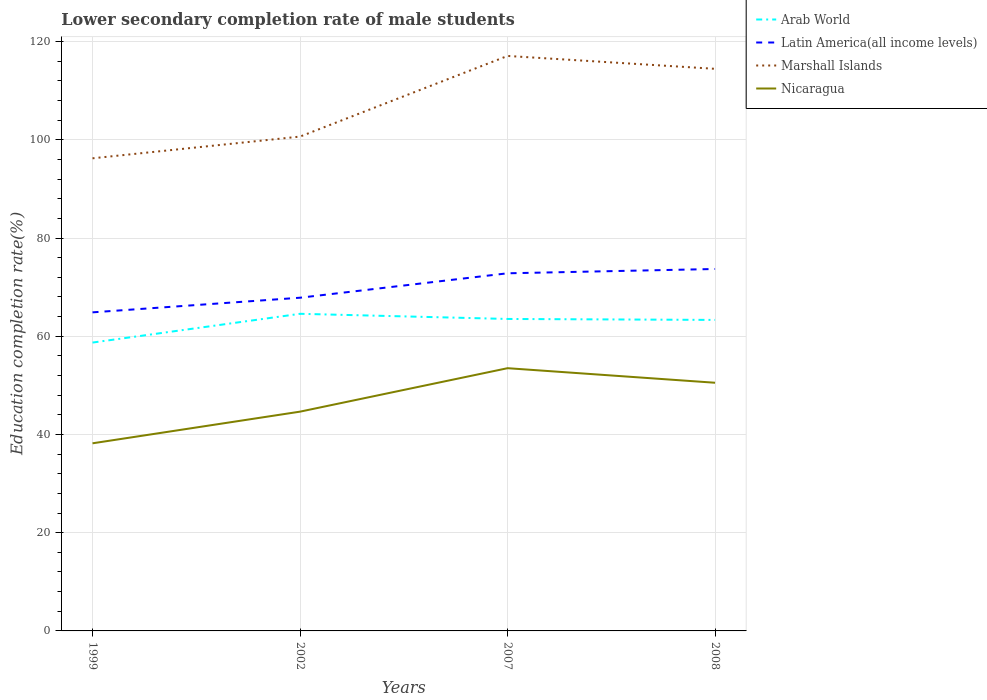Does the line corresponding to Marshall Islands intersect with the line corresponding to Nicaragua?
Your answer should be compact. No. Is the number of lines equal to the number of legend labels?
Give a very brief answer. Yes. Across all years, what is the maximum lower secondary completion rate of male students in Arab World?
Provide a short and direct response. 58.71. In which year was the lower secondary completion rate of male students in Marshall Islands maximum?
Provide a succinct answer. 1999. What is the total lower secondary completion rate of male students in Arab World in the graph?
Offer a terse response. 0.2. What is the difference between the highest and the second highest lower secondary completion rate of male students in Latin America(all income levels)?
Offer a very short reply. 8.83. What is the difference between the highest and the lowest lower secondary completion rate of male students in Nicaragua?
Provide a succinct answer. 2. Is the lower secondary completion rate of male students in Nicaragua strictly greater than the lower secondary completion rate of male students in Arab World over the years?
Your answer should be compact. Yes. What is the difference between two consecutive major ticks on the Y-axis?
Your response must be concise. 20. Are the values on the major ticks of Y-axis written in scientific E-notation?
Ensure brevity in your answer.  No. Does the graph contain grids?
Your answer should be compact. Yes. Where does the legend appear in the graph?
Your response must be concise. Top right. How many legend labels are there?
Make the answer very short. 4. What is the title of the graph?
Your answer should be compact. Lower secondary completion rate of male students. What is the label or title of the Y-axis?
Provide a short and direct response. Education completion rate(%). What is the Education completion rate(%) of Arab World in 1999?
Your answer should be compact. 58.71. What is the Education completion rate(%) of Latin America(all income levels) in 1999?
Your response must be concise. 64.86. What is the Education completion rate(%) in Marshall Islands in 1999?
Your response must be concise. 96.23. What is the Education completion rate(%) in Nicaragua in 1999?
Offer a terse response. 38.2. What is the Education completion rate(%) of Arab World in 2002?
Keep it short and to the point. 64.57. What is the Education completion rate(%) in Latin America(all income levels) in 2002?
Provide a short and direct response. 67.84. What is the Education completion rate(%) of Marshall Islands in 2002?
Give a very brief answer. 100.65. What is the Education completion rate(%) of Nicaragua in 2002?
Provide a succinct answer. 44.65. What is the Education completion rate(%) in Arab World in 2007?
Your answer should be compact. 63.52. What is the Education completion rate(%) in Latin America(all income levels) in 2007?
Offer a terse response. 72.81. What is the Education completion rate(%) of Marshall Islands in 2007?
Your answer should be compact. 117.07. What is the Education completion rate(%) of Nicaragua in 2007?
Make the answer very short. 53.49. What is the Education completion rate(%) of Arab World in 2008?
Offer a very short reply. 63.32. What is the Education completion rate(%) in Latin America(all income levels) in 2008?
Your response must be concise. 73.69. What is the Education completion rate(%) in Marshall Islands in 2008?
Offer a terse response. 114.44. What is the Education completion rate(%) in Nicaragua in 2008?
Your answer should be very brief. 50.53. Across all years, what is the maximum Education completion rate(%) in Arab World?
Your answer should be very brief. 64.57. Across all years, what is the maximum Education completion rate(%) in Latin America(all income levels)?
Offer a very short reply. 73.69. Across all years, what is the maximum Education completion rate(%) of Marshall Islands?
Offer a terse response. 117.07. Across all years, what is the maximum Education completion rate(%) in Nicaragua?
Keep it short and to the point. 53.49. Across all years, what is the minimum Education completion rate(%) in Arab World?
Give a very brief answer. 58.71. Across all years, what is the minimum Education completion rate(%) of Latin America(all income levels)?
Offer a very short reply. 64.86. Across all years, what is the minimum Education completion rate(%) of Marshall Islands?
Give a very brief answer. 96.23. Across all years, what is the minimum Education completion rate(%) of Nicaragua?
Provide a succinct answer. 38.2. What is the total Education completion rate(%) in Arab World in the graph?
Provide a succinct answer. 250.12. What is the total Education completion rate(%) of Latin America(all income levels) in the graph?
Your answer should be compact. 279.21. What is the total Education completion rate(%) of Marshall Islands in the graph?
Make the answer very short. 428.39. What is the total Education completion rate(%) of Nicaragua in the graph?
Provide a succinct answer. 186.87. What is the difference between the Education completion rate(%) in Arab World in 1999 and that in 2002?
Your response must be concise. -5.85. What is the difference between the Education completion rate(%) of Latin America(all income levels) in 1999 and that in 2002?
Your response must be concise. -2.98. What is the difference between the Education completion rate(%) in Marshall Islands in 1999 and that in 2002?
Provide a succinct answer. -4.42. What is the difference between the Education completion rate(%) in Nicaragua in 1999 and that in 2002?
Your answer should be very brief. -6.45. What is the difference between the Education completion rate(%) of Arab World in 1999 and that in 2007?
Keep it short and to the point. -4.81. What is the difference between the Education completion rate(%) of Latin America(all income levels) in 1999 and that in 2007?
Offer a terse response. -7.95. What is the difference between the Education completion rate(%) of Marshall Islands in 1999 and that in 2007?
Make the answer very short. -20.84. What is the difference between the Education completion rate(%) in Nicaragua in 1999 and that in 2007?
Your answer should be compact. -15.29. What is the difference between the Education completion rate(%) of Arab World in 1999 and that in 2008?
Provide a succinct answer. -4.61. What is the difference between the Education completion rate(%) of Latin America(all income levels) in 1999 and that in 2008?
Offer a terse response. -8.83. What is the difference between the Education completion rate(%) of Marshall Islands in 1999 and that in 2008?
Offer a terse response. -18.22. What is the difference between the Education completion rate(%) of Nicaragua in 1999 and that in 2008?
Your answer should be compact. -12.33. What is the difference between the Education completion rate(%) of Arab World in 2002 and that in 2007?
Provide a short and direct response. 1.05. What is the difference between the Education completion rate(%) in Latin America(all income levels) in 2002 and that in 2007?
Your answer should be compact. -4.97. What is the difference between the Education completion rate(%) in Marshall Islands in 2002 and that in 2007?
Your answer should be very brief. -16.42. What is the difference between the Education completion rate(%) of Nicaragua in 2002 and that in 2007?
Keep it short and to the point. -8.85. What is the difference between the Education completion rate(%) in Arab World in 2002 and that in 2008?
Provide a succinct answer. 1.25. What is the difference between the Education completion rate(%) in Latin America(all income levels) in 2002 and that in 2008?
Give a very brief answer. -5.85. What is the difference between the Education completion rate(%) of Marshall Islands in 2002 and that in 2008?
Make the answer very short. -13.79. What is the difference between the Education completion rate(%) of Nicaragua in 2002 and that in 2008?
Offer a very short reply. -5.88. What is the difference between the Education completion rate(%) in Arab World in 2007 and that in 2008?
Give a very brief answer. 0.2. What is the difference between the Education completion rate(%) in Latin America(all income levels) in 2007 and that in 2008?
Your answer should be compact. -0.88. What is the difference between the Education completion rate(%) of Marshall Islands in 2007 and that in 2008?
Ensure brevity in your answer.  2.62. What is the difference between the Education completion rate(%) in Nicaragua in 2007 and that in 2008?
Make the answer very short. 2.96. What is the difference between the Education completion rate(%) in Arab World in 1999 and the Education completion rate(%) in Latin America(all income levels) in 2002?
Provide a succinct answer. -9.13. What is the difference between the Education completion rate(%) of Arab World in 1999 and the Education completion rate(%) of Marshall Islands in 2002?
Keep it short and to the point. -41.94. What is the difference between the Education completion rate(%) in Arab World in 1999 and the Education completion rate(%) in Nicaragua in 2002?
Make the answer very short. 14.07. What is the difference between the Education completion rate(%) in Latin America(all income levels) in 1999 and the Education completion rate(%) in Marshall Islands in 2002?
Keep it short and to the point. -35.79. What is the difference between the Education completion rate(%) of Latin America(all income levels) in 1999 and the Education completion rate(%) of Nicaragua in 2002?
Offer a very short reply. 20.22. What is the difference between the Education completion rate(%) of Marshall Islands in 1999 and the Education completion rate(%) of Nicaragua in 2002?
Provide a short and direct response. 51.58. What is the difference between the Education completion rate(%) of Arab World in 1999 and the Education completion rate(%) of Latin America(all income levels) in 2007?
Keep it short and to the point. -14.1. What is the difference between the Education completion rate(%) in Arab World in 1999 and the Education completion rate(%) in Marshall Islands in 2007?
Keep it short and to the point. -58.36. What is the difference between the Education completion rate(%) in Arab World in 1999 and the Education completion rate(%) in Nicaragua in 2007?
Provide a short and direct response. 5.22. What is the difference between the Education completion rate(%) of Latin America(all income levels) in 1999 and the Education completion rate(%) of Marshall Islands in 2007?
Keep it short and to the point. -52.2. What is the difference between the Education completion rate(%) in Latin America(all income levels) in 1999 and the Education completion rate(%) in Nicaragua in 2007?
Your response must be concise. 11.37. What is the difference between the Education completion rate(%) of Marshall Islands in 1999 and the Education completion rate(%) of Nicaragua in 2007?
Provide a short and direct response. 42.73. What is the difference between the Education completion rate(%) in Arab World in 1999 and the Education completion rate(%) in Latin America(all income levels) in 2008?
Your response must be concise. -14.98. What is the difference between the Education completion rate(%) in Arab World in 1999 and the Education completion rate(%) in Marshall Islands in 2008?
Make the answer very short. -55.73. What is the difference between the Education completion rate(%) of Arab World in 1999 and the Education completion rate(%) of Nicaragua in 2008?
Keep it short and to the point. 8.18. What is the difference between the Education completion rate(%) of Latin America(all income levels) in 1999 and the Education completion rate(%) of Marshall Islands in 2008?
Keep it short and to the point. -49.58. What is the difference between the Education completion rate(%) in Latin America(all income levels) in 1999 and the Education completion rate(%) in Nicaragua in 2008?
Your answer should be very brief. 14.33. What is the difference between the Education completion rate(%) in Marshall Islands in 1999 and the Education completion rate(%) in Nicaragua in 2008?
Make the answer very short. 45.7. What is the difference between the Education completion rate(%) of Arab World in 2002 and the Education completion rate(%) of Latin America(all income levels) in 2007?
Provide a succinct answer. -8.25. What is the difference between the Education completion rate(%) of Arab World in 2002 and the Education completion rate(%) of Marshall Islands in 2007?
Your response must be concise. -52.5. What is the difference between the Education completion rate(%) of Arab World in 2002 and the Education completion rate(%) of Nicaragua in 2007?
Offer a terse response. 11.07. What is the difference between the Education completion rate(%) of Latin America(all income levels) in 2002 and the Education completion rate(%) of Marshall Islands in 2007?
Keep it short and to the point. -49.23. What is the difference between the Education completion rate(%) of Latin America(all income levels) in 2002 and the Education completion rate(%) of Nicaragua in 2007?
Provide a succinct answer. 14.35. What is the difference between the Education completion rate(%) in Marshall Islands in 2002 and the Education completion rate(%) in Nicaragua in 2007?
Provide a succinct answer. 47.16. What is the difference between the Education completion rate(%) of Arab World in 2002 and the Education completion rate(%) of Latin America(all income levels) in 2008?
Ensure brevity in your answer.  -9.12. What is the difference between the Education completion rate(%) in Arab World in 2002 and the Education completion rate(%) in Marshall Islands in 2008?
Ensure brevity in your answer.  -49.88. What is the difference between the Education completion rate(%) in Arab World in 2002 and the Education completion rate(%) in Nicaragua in 2008?
Make the answer very short. 14.04. What is the difference between the Education completion rate(%) in Latin America(all income levels) in 2002 and the Education completion rate(%) in Marshall Islands in 2008?
Offer a terse response. -46.6. What is the difference between the Education completion rate(%) in Latin America(all income levels) in 2002 and the Education completion rate(%) in Nicaragua in 2008?
Offer a very short reply. 17.31. What is the difference between the Education completion rate(%) in Marshall Islands in 2002 and the Education completion rate(%) in Nicaragua in 2008?
Your answer should be compact. 50.12. What is the difference between the Education completion rate(%) in Arab World in 2007 and the Education completion rate(%) in Latin America(all income levels) in 2008?
Provide a succinct answer. -10.17. What is the difference between the Education completion rate(%) in Arab World in 2007 and the Education completion rate(%) in Marshall Islands in 2008?
Your response must be concise. -50.93. What is the difference between the Education completion rate(%) of Arab World in 2007 and the Education completion rate(%) of Nicaragua in 2008?
Provide a succinct answer. 12.99. What is the difference between the Education completion rate(%) in Latin America(all income levels) in 2007 and the Education completion rate(%) in Marshall Islands in 2008?
Your answer should be compact. -41.63. What is the difference between the Education completion rate(%) in Latin America(all income levels) in 2007 and the Education completion rate(%) in Nicaragua in 2008?
Provide a short and direct response. 22.29. What is the difference between the Education completion rate(%) in Marshall Islands in 2007 and the Education completion rate(%) in Nicaragua in 2008?
Provide a succinct answer. 66.54. What is the average Education completion rate(%) of Arab World per year?
Ensure brevity in your answer.  62.53. What is the average Education completion rate(%) of Latin America(all income levels) per year?
Provide a short and direct response. 69.8. What is the average Education completion rate(%) in Marshall Islands per year?
Your answer should be very brief. 107.1. What is the average Education completion rate(%) in Nicaragua per year?
Your answer should be very brief. 46.72. In the year 1999, what is the difference between the Education completion rate(%) in Arab World and Education completion rate(%) in Latin America(all income levels)?
Keep it short and to the point. -6.15. In the year 1999, what is the difference between the Education completion rate(%) of Arab World and Education completion rate(%) of Marshall Islands?
Your answer should be compact. -37.51. In the year 1999, what is the difference between the Education completion rate(%) in Arab World and Education completion rate(%) in Nicaragua?
Keep it short and to the point. 20.51. In the year 1999, what is the difference between the Education completion rate(%) of Latin America(all income levels) and Education completion rate(%) of Marshall Islands?
Your answer should be compact. -31.36. In the year 1999, what is the difference between the Education completion rate(%) of Latin America(all income levels) and Education completion rate(%) of Nicaragua?
Make the answer very short. 26.66. In the year 1999, what is the difference between the Education completion rate(%) of Marshall Islands and Education completion rate(%) of Nicaragua?
Make the answer very short. 58.03. In the year 2002, what is the difference between the Education completion rate(%) of Arab World and Education completion rate(%) of Latin America(all income levels)?
Give a very brief answer. -3.28. In the year 2002, what is the difference between the Education completion rate(%) of Arab World and Education completion rate(%) of Marshall Islands?
Offer a very short reply. -36.08. In the year 2002, what is the difference between the Education completion rate(%) in Arab World and Education completion rate(%) in Nicaragua?
Your response must be concise. 19.92. In the year 2002, what is the difference between the Education completion rate(%) of Latin America(all income levels) and Education completion rate(%) of Marshall Islands?
Offer a terse response. -32.81. In the year 2002, what is the difference between the Education completion rate(%) in Latin America(all income levels) and Education completion rate(%) in Nicaragua?
Make the answer very short. 23.2. In the year 2002, what is the difference between the Education completion rate(%) of Marshall Islands and Education completion rate(%) of Nicaragua?
Make the answer very short. 56.01. In the year 2007, what is the difference between the Education completion rate(%) of Arab World and Education completion rate(%) of Latin America(all income levels)?
Make the answer very short. -9.3. In the year 2007, what is the difference between the Education completion rate(%) of Arab World and Education completion rate(%) of Marshall Islands?
Ensure brevity in your answer.  -53.55. In the year 2007, what is the difference between the Education completion rate(%) in Arab World and Education completion rate(%) in Nicaragua?
Offer a very short reply. 10.02. In the year 2007, what is the difference between the Education completion rate(%) of Latin America(all income levels) and Education completion rate(%) of Marshall Islands?
Provide a succinct answer. -44.25. In the year 2007, what is the difference between the Education completion rate(%) in Latin America(all income levels) and Education completion rate(%) in Nicaragua?
Provide a short and direct response. 19.32. In the year 2007, what is the difference between the Education completion rate(%) in Marshall Islands and Education completion rate(%) in Nicaragua?
Offer a very short reply. 63.58. In the year 2008, what is the difference between the Education completion rate(%) of Arab World and Education completion rate(%) of Latin America(all income levels)?
Your answer should be very brief. -10.37. In the year 2008, what is the difference between the Education completion rate(%) in Arab World and Education completion rate(%) in Marshall Islands?
Keep it short and to the point. -51.12. In the year 2008, what is the difference between the Education completion rate(%) of Arab World and Education completion rate(%) of Nicaragua?
Give a very brief answer. 12.79. In the year 2008, what is the difference between the Education completion rate(%) of Latin America(all income levels) and Education completion rate(%) of Marshall Islands?
Give a very brief answer. -40.75. In the year 2008, what is the difference between the Education completion rate(%) in Latin America(all income levels) and Education completion rate(%) in Nicaragua?
Make the answer very short. 23.16. In the year 2008, what is the difference between the Education completion rate(%) in Marshall Islands and Education completion rate(%) in Nicaragua?
Offer a terse response. 63.91. What is the ratio of the Education completion rate(%) of Arab World in 1999 to that in 2002?
Keep it short and to the point. 0.91. What is the ratio of the Education completion rate(%) of Latin America(all income levels) in 1999 to that in 2002?
Give a very brief answer. 0.96. What is the ratio of the Education completion rate(%) of Marshall Islands in 1999 to that in 2002?
Your answer should be very brief. 0.96. What is the ratio of the Education completion rate(%) of Nicaragua in 1999 to that in 2002?
Make the answer very short. 0.86. What is the ratio of the Education completion rate(%) of Arab World in 1999 to that in 2007?
Your response must be concise. 0.92. What is the ratio of the Education completion rate(%) of Latin America(all income levels) in 1999 to that in 2007?
Your answer should be very brief. 0.89. What is the ratio of the Education completion rate(%) in Marshall Islands in 1999 to that in 2007?
Your answer should be very brief. 0.82. What is the ratio of the Education completion rate(%) of Nicaragua in 1999 to that in 2007?
Give a very brief answer. 0.71. What is the ratio of the Education completion rate(%) in Arab World in 1999 to that in 2008?
Make the answer very short. 0.93. What is the ratio of the Education completion rate(%) of Latin America(all income levels) in 1999 to that in 2008?
Offer a terse response. 0.88. What is the ratio of the Education completion rate(%) in Marshall Islands in 1999 to that in 2008?
Your response must be concise. 0.84. What is the ratio of the Education completion rate(%) of Nicaragua in 1999 to that in 2008?
Offer a terse response. 0.76. What is the ratio of the Education completion rate(%) in Arab World in 2002 to that in 2007?
Ensure brevity in your answer.  1.02. What is the ratio of the Education completion rate(%) in Latin America(all income levels) in 2002 to that in 2007?
Offer a very short reply. 0.93. What is the ratio of the Education completion rate(%) of Marshall Islands in 2002 to that in 2007?
Offer a terse response. 0.86. What is the ratio of the Education completion rate(%) in Nicaragua in 2002 to that in 2007?
Keep it short and to the point. 0.83. What is the ratio of the Education completion rate(%) of Arab World in 2002 to that in 2008?
Your answer should be very brief. 1.02. What is the ratio of the Education completion rate(%) in Latin America(all income levels) in 2002 to that in 2008?
Your response must be concise. 0.92. What is the ratio of the Education completion rate(%) of Marshall Islands in 2002 to that in 2008?
Offer a very short reply. 0.88. What is the ratio of the Education completion rate(%) of Nicaragua in 2002 to that in 2008?
Offer a very short reply. 0.88. What is the ratio of the Education completion rate(%) of Latin America(all income levels) in 2007 to that in 2008?
Your response must be concise. 0.99. What is the ratio of the Education completion rate(%) of Marshall Islands in 2007 to that in 2008?
Offer a terse response. 1.02. What is the ratio of the Education completion rate(%) in Nicaragua in 2007 to that in 2008?
Your answer should be very brief. 1.06. What is the difference between the highest and the second highest Education completion rate(%) in Arab World?
Your response must be concise. 1.05. What is the difference between the highest and the second highest Education completion rate(%) in Latin America(all income levels)?
Offer a very short reply. 0.88. What is the difference between the highest and the second highest Education completion rate(%) of Marshall Islands?
Offer a terse response. 2.62. What is the difference between the highest and the second highest Education completion rate(%) of Nicaragua?
Your answer should be very brief. 2.96. What is the difference between the highest and the lowest Education completion rate(%) in Arab World?
Your answer should be compact. 5.85. What is the difference between the highest and the lowest Education completion rate(%) of Latin America(all income levels)?
Keep it short and to the point. 8.83. What is the difference between the highest and the lowest Education completion rate(%) in Marshall Islands?
Make the answer very short. 20.84. What is the difference between the highest and the lowest Education completion rate(%) of Nicaragua?
Keep it short and to the point. 15.29. 